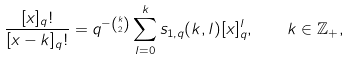Convert formula to latex. <formula><loc_0><loc_0><loc_500><loc_500>\frac { [ x ] _ { q } ! } { [ x - k ] _ { q } ! } = q ^ { - \binom { k } { 2 } } \sum _ { l = 0 } ^ { k } s _ { 1 , q } ( k , l ) [ x ] _ { q } ^ { l } , \quad k \in \mathbb { Z } _ { + } ,</formula> 